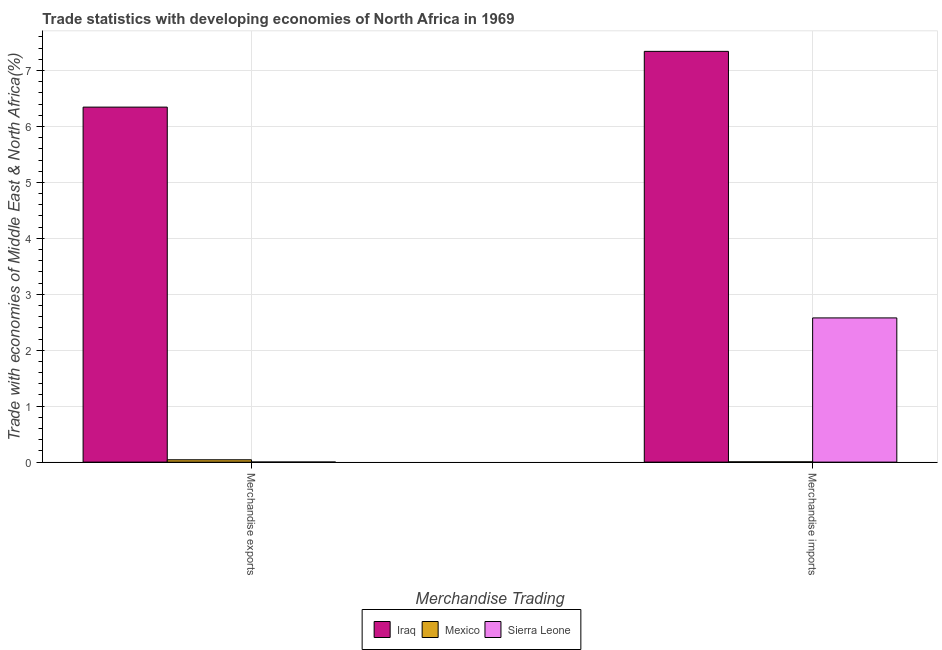How many groups of bars are there?
Provide a succinct answer. 2. Are the number of bars on each tick of the X-axis equal?
Ensure brevity in your answer.  Yes. How many bars are there on the 1st tick from the right?
Offer a very short reply. 3. What is the label of the 2nd group of bars from the left?
Offer a very short reply. Merchandise imports. What is the merchandise imports in Sierra Leone?
Offer a very short reply. 2.58. Across all countries, what is the maximum merchandise imports?
Offer a very short reply. 7.34. Across all countries, what is the minimum merchandise imports?
Provide a succinct answer. 0. In which country was the merchandise imports maximum?
Offer a terse response. Iraq. In which country was the merchandise exports minimum?
Your answer should be very brief. Sierra Leone. What is the total merchandise exports in the graph?
Give a very brief answer. 6.39. What is the difference between the merchandise imports in Sierra Leone and that in Mexico?
Your answer should be very brief. 2.57. What is the difference between the merchandise imports in Iraq and the merchandise exports in Mexico?
Provide a short and direct response. 7.3. What is the average merchandise exports per country?
Your answer should be very brief. 2.13. What is the difference between the merchandise exports and merchandise imports in Mexico?
Your answer should be very brief. 0.04. What is the ratio of the merchandise imports in Sierra Leone to that in Mexico?
Your answer should be very brief. 535.36. What does the 3rd bar from the left in Merchandise exports represents?
Your response must be concise. Sierra Leone. What does the 3rd bar from the right in Merchandise imports represents?
Offer a terse response. Iraq. How many bars are there?
Ensure brevity in your answer.  6. Are the values on the major ticks of Y-axis written in scientific E-notation?
Give a very brief answer. No. Does the graph contain any zero values?
Ensure brevity in your answer.  No. Does the graph contain grids?
Keep it short and to the point. Yes. What is the title of the graph?
Your answer should be compact. Trade statistics with developing economies of North Africa in 1969. What is the label or title of the X-axis?
Offer a terse response. Merchandise Trading. What is the label or title of the Y-axis?
Offer a terse response. Trade with economies of Middle East & North Africa(%). What is the Trade with economies of Middle East & North Africa(%) of Iraq in Merchandise exports?
Give a very brief answer. 6.35. What is the Trade with economies of Middle East & North Africa(%) in Mexico in Merchandise exports?
Ensure brevity in your answer.  0.04. What is the Trade with economies of Middle East & North Africa(%) in Sierra Leone in Merchandise exports?
Your answer should be very brief. 0. What is the Trade with economies of Middle East & North Africa(%) of Iraq in Merchandise imports?
Offer a terse response. 7.34. What is the Trade with economies of Middle East & North Africa(%) of Mexico in Merchandise imports?
Give a very brief answer. 0. What is the Trade with economies of Middle East & North Africa(%) in Sierra Leone in Merchandise imports?
Ensure brevity in your answer.  2.58. Across all Merchandise Trading, what is the maximum Trade with economies of Middle East & North Africa(%) of Iraq?
Your response must be concise. 7.34. Across all Merchandise Trading, what is the maximum Trade with economies of Middle East & North Africa(%) of Mexico?
Give a very brief answer. 0.04. Across all Merchandise Trading, what is the maximum Trade with economies of Middle East & North Africa(%) in Sierra Leone?
Keep it short and to the point. 2.58. Across all Merchandise Trading, what is the minimum Trade with economies of Middle East & North Africa(%) of Iraq?
Provide a succinct answer. 6.35. Across all Merchandise Trading, what is the minimum Trade with economies of Middle East & North Africa(%) of Mexico?
Give a very brief answer. 0. Across all Merchandise Trading, what is the minimum Trade with economies of Middle East & North Africa(%) of Sierra Leone?
Give a very brief answer. 0. What is the total Trade with economies of Middle East & North Africa(%) of Iraq in the graph?
Offer a terse response. 13.69. What is the total Trade with economies of Middle East & North Africa(%) in Mexico in the graph?
Ensure brevity in your answer.  0.05. What is the total Trade with economies of Middle East & North Africa(%) in Sierra Leone in the graph?
Your answer should be compact. 2.58. What is the difference between the Trade with economies of Middle East & North Africa(%) in Iraq in Merchandise exports and that in Merchandise imports?
Ensure brevity in your answer.  -1. What is the difference between the Trade with economies of Middle East & North Africa(%) of Mexico in Merchandise exports and that in Merchandise imports?
Your response must be concise. 0.04. What is the difference between the Trade with economies of Middle East & North Africa(%) in Sierra Leone in Merchandise exports and that in Merchandise imports?
Provide a short and direct response. -2.58. What is the difference between the Trade with economies of Middle East & North Africa(%) of Iraq in Merchandise exports and the Trade with economies of Middle East & North Africa(%) of Mexico in Merchandise imports?
Ensure brevity in your answer.  6.34. What is the difference between the Trade with economies of Middle East & North Africa(%) of Iraq in Merchandise exports and the Trade with economies of Middle East & North Africa(%) of Sierra Leone in Merchandise imports?
Ensure brevity in your answer.  3.77. What is the difference between the Trade with economies of Middle East & North Africa(%) in Mexico in Merchandise exports and the Trade with economies of Middle East & North Africa(%) in Sierra Leone in Merchandise imports?
Provide a succinct answer. -2.54. What is the average Trade with economies of Middle East & North Africa(%) of Iraq per Merchandise Trading?
Your response must be concise. 6.84. What is the average Trade with economies of Middle East & North Africa(%) in Mexico per Merchandise Trading?
Offer a very short reply. 0.02. What is the average Trade with economies of Middle East & North Africa(%) in Sierra Leone per Merchandise Trading?
Make the answer very short. 1.29. What is the difference between the Trade with economies of Middle East & North Africa(%) of Iraq and Trade with economies of Middle East & North Africa(%) of Mexico in Merchandise exports?
Provide a succinct answer. 6.3. What is the difference between the Trade with economies of Middle East & North Africa(%) in Iraq and Trade with economies of Middle East & North Africa(%) in Sierra Leone in Merchandise exports?
Give a very brief answer. 6.34. What is the difference between the Trade with economies of Middle East & North Africa(%) in Mexico and Trade with economies of Middle East & North Africa(%) in Sierra Leone in Merchandise exports?
Give a very brief answer. 0.04. What is the difference between the Trade with economies of Middle East & North Africa(%) of Iraq and Trade with economies of Middle East & North Africa(%) of Mexico in Merchandise imports?
Make the answer very short. 7.34. What is the difference between the Trade with economies of Middle East & North Africa(%) of Iraq and Trade with economies of Middle East & North Africa(%) of Sierra Leone in Merchandise imports?
Provide a succinct answer. 4.76. What is the difference between the Trade with economies of Middle East & North Africa(%) of Mexico and Trade with economies of Middle East & North Africa(%) of Sierra Leone in Merchandise imports?
Provide a succinct answer. -2.57. What is the ratio of the Trade with economies of Middle East & North Africa(%) of Iraq in Merchandise exports to that in Merchandise imports?
Ensure brevity in your answer.  0.86. What is the ratio of the Trade with economies of Middle East & North Africa(%) in Mexico in Merchandise exports to that in Merchandise imports?
Offer a terse response. 8.72. What is the ratio of the Trade with economies of Middle East & North Africa(%) of Sierra Leone in Merchandise exports to that in Merchandise imports?
Your response must be concise. 0. What is the difference between the highest and the second highest Trade with economies of Middle East & North Africa(%) of Iraq?
Provide a short and direct response. 1. What is the difference between the highest and the second highest Trade with economies of Middle East & North Africa(%) of Mexico?
Provide a succinct answer. 0.04. What is the difference between the highest and the second highest Trade with economies of Middle East & North Africa(%) in Sierra Leone?
Offer a terse response. 2.58. What is the difference between the highest and the lowest Trade with economies of Middle East & North Africa(%) of Mexico?
Offer a terse response. 0.04. What is the difference between the highest and the lowest Trade with economies of Middle East & North Africa(%) of Sierra Leone?
Provide a succinct answer. 2.58. 